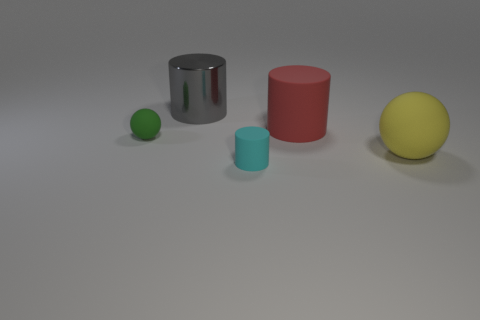Add 2 tiny brown blocks. How many objects exist? 7 Subtract all yellow spheres. How many spheres are left? 1 Subtract all large cylinders. How many cylinders are left? 1 Subtract 0 gray balls. How many objects are left? 5 Subtract all cylinders. How many objects are left? 2 Subtract 1 cylinders. How many cylinders are left? 2 Subtract all purple spheres. Subtract all green cylinders. How many spheres are left? 2 Subtract all gray blocks. How many brown cylinders are left? 0 Subtract all brown shiny balls. Subtract all yellow balls. How many objects are left? 4 Add 1 big red matte things. How many big red matte things are left? 2 